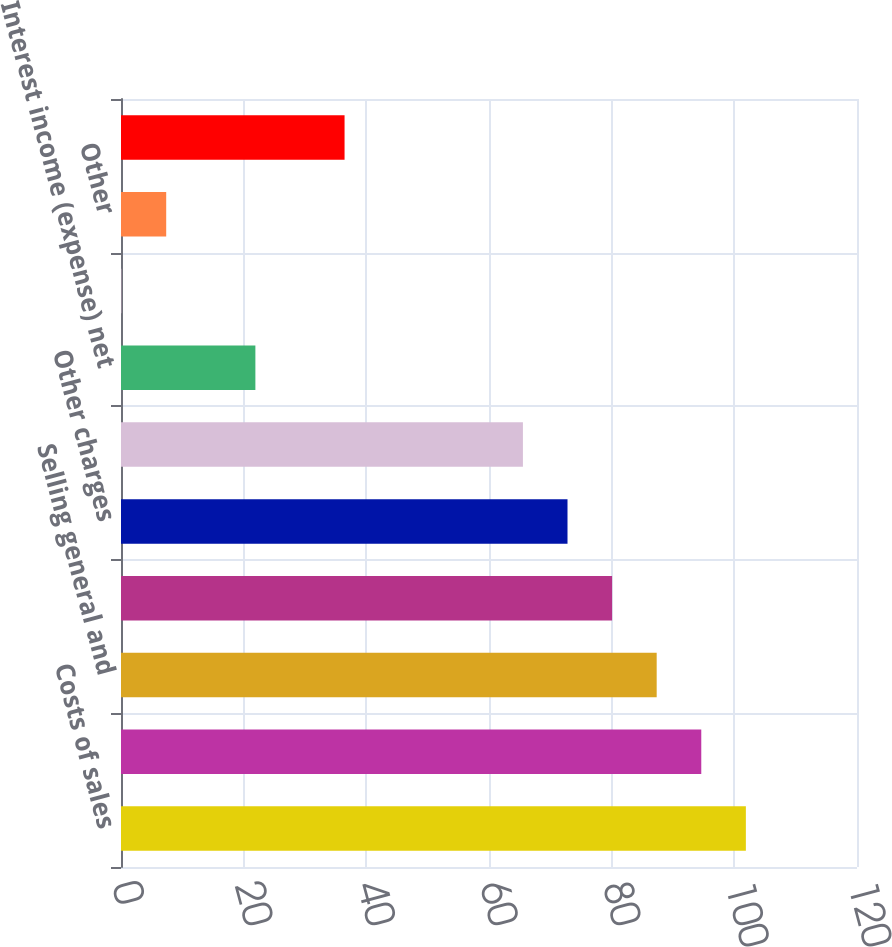Convert chart to OTSL. <chart><loc_0><loc_0><loc_500><loc_500><bar_chart><fcel>Costs of sales<fcel>Gross margin<fcel>Selling general and<fcel>Research and development<fcel>Other charges<fcel>Operating loss<fcel>Interest income (expense) net<fcel>Gains on sales of investments<fcel>Other<fcel>Total other income (expense)<nl><fcel>101.88<fcel>94.61<fcel>87.34<fcel>80.07<fcel>72.8<fcel>65.53<fcel>21.91<fcel>0.1<fcel>7.37<fcel>36.45<nl></chart> 